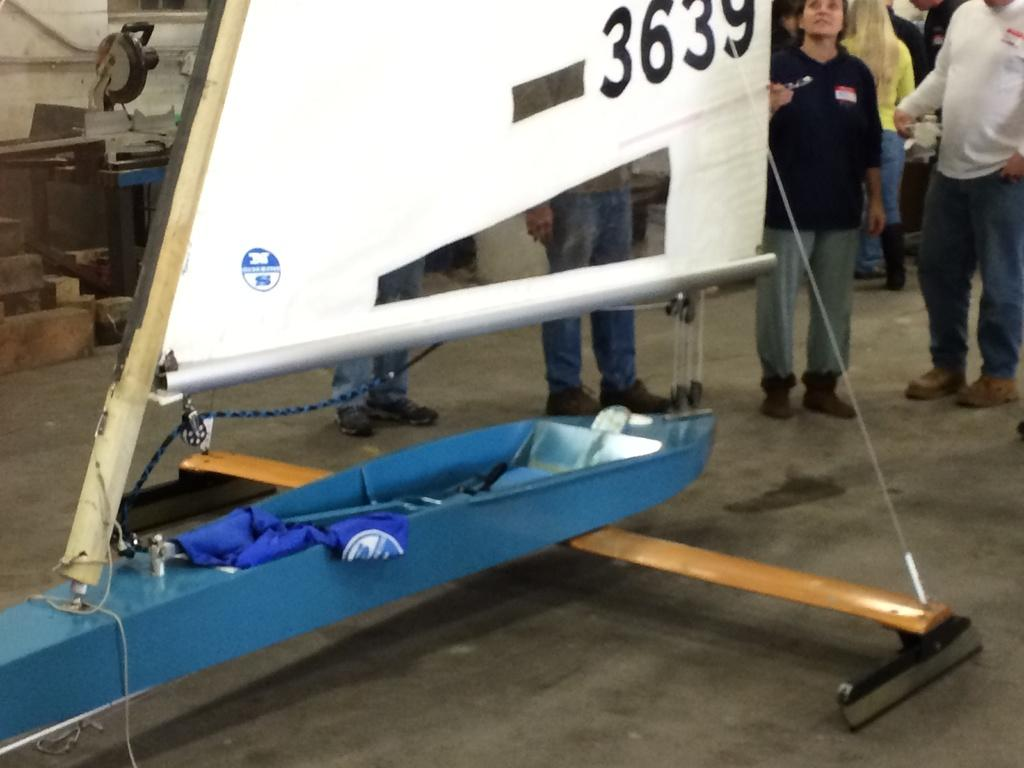<image>
Render a clear and concise summary of the photo. A model of a 3639 boat is displayed in an exhibit. 